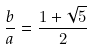Convert formula to latex. <formula><loc_0><loc_0><loc_500><loc_500>\frac { b } { a } = \frac { 1 + \sqrt { 5 } } { 2 }</formula> 